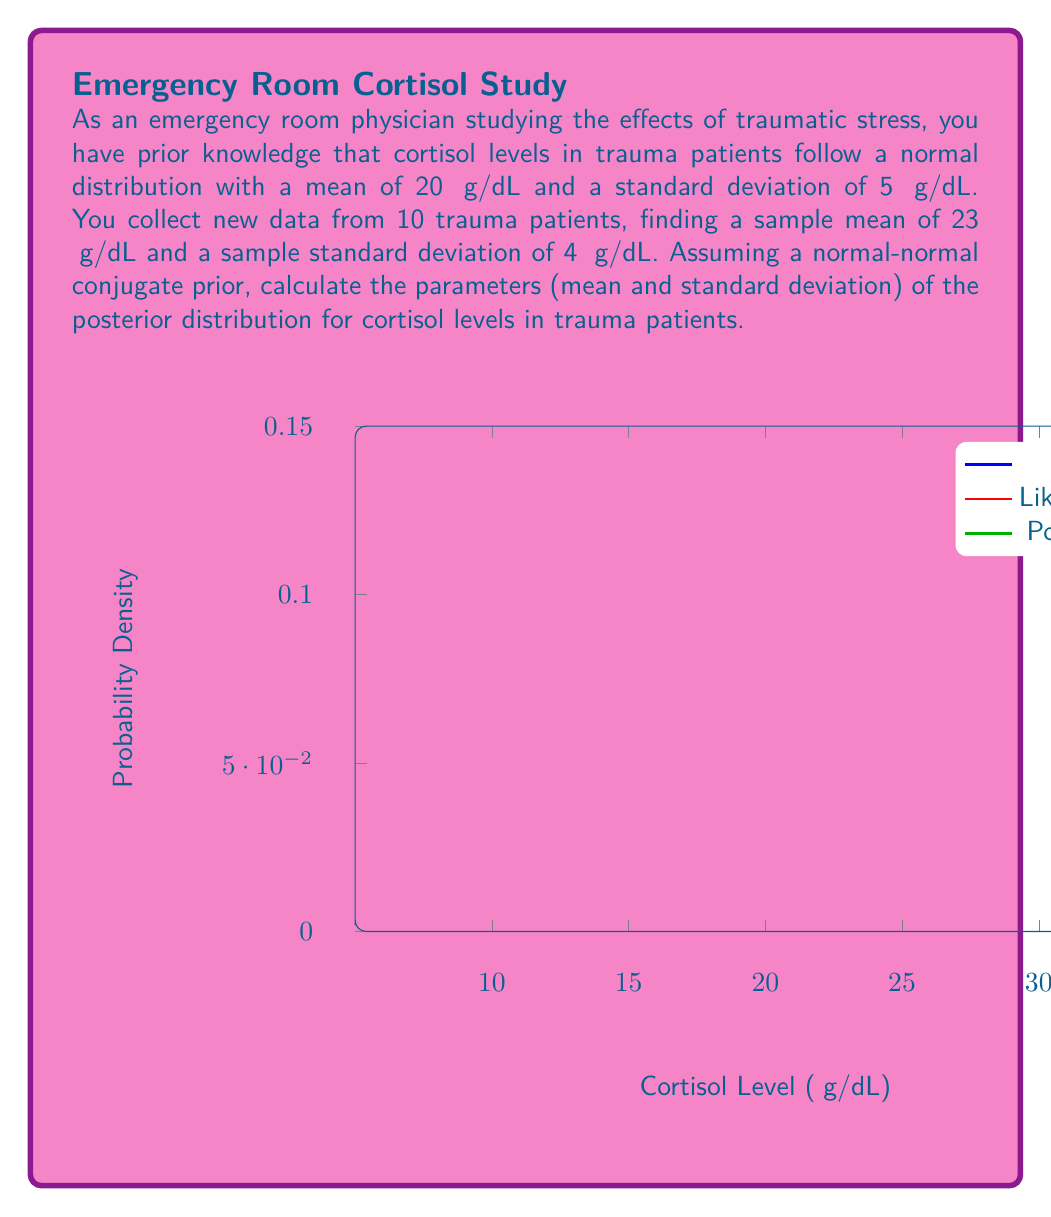Teach me how to tackle this problem. To solve this problem, we'll use the formulas for updating a normal prior with normal data:

1) Let's define our variables:
   $\mu_0 = 20$ (prior mean)
   $\sigma_0 = 5$ (prior standard deviation)
   $\bar{x} = 23$ (sample mean)
   $s = 4$ (sample standard deviation)
   $n = 10$ (sample size)

2) Calculate the precision (inverse of variance) for prior and data:
   $\tau_0 = \frac{1}{\sigma_0^2} = \frac{1}{5^2} = 0.04$
   $\tau_{\text{data}} = \frac{n}{s^2} = \frac{10}{4^2} = 0.625$

3) Calculate the posterior precision:
   $\tau_n = \tau_0 + \tau_{\text{data}} = 0.04 + 0.625 = 0.665$

4) Calculate the posterior mean:
   $\mu_n = \frac{\tau_0 \mu_0 + \tau_{\text{data}} \bar{x}}{\tau_n}$
   $\mu_n = \frac{0.04 \cdot 20 + 0.625 \cdot 23}{0.665} \approx 22.2$

5) Calculate the posterior standard deviation:
   $\sigma_n = \frac{1}{\sqrt{\tau_n}} = \frac{1}{\sqrt{0.665}} \approx 2.8$

Thus, the posterior distribution is normal with mean $\mu_n \approx 22.2$ and standard deviation $\sigma_n \approx 2.8$.
Answer: $N(22.2, 2.8^2)$ 